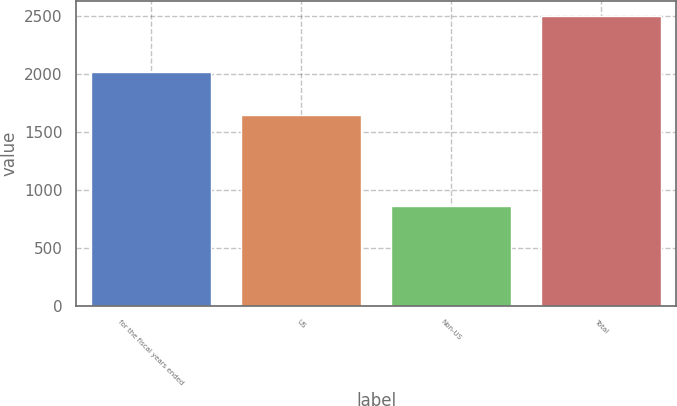<chart> <loc_0><loc_0><loc_500><loc_500><bar_chart><fcel>for the fiscal years ended<fcel>US<fcel>Non-US<fcel>Total<nl><fcel>2016<fcel>1641.7<fcel>858.1<fcel>2499.8<nl></chart> 